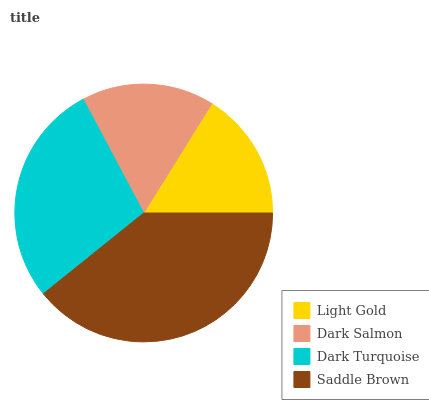Is Light Gold the minimum?
Answer yes or no. Yes. Is Saddle Brown the maximum?
Answer yes or no. Yes. Is Dark Salmon the minimum?
Answer yes or no. No. Is Dark Salmon the maximum?
Answer yes or no. No. Is Dark Salmon greater than Light Gold?
Answer yes or no. Yes. Is Light Gold less than Dark Salmon?
Answer yes or no. Yes. Is Light Gold greater than Dark Salmon?
Answer yes or no. No. Is Dark Salmon less than Light Gold?
Answer yes or no. No. Is Dark Turquoise the high median?
Answer yes or no. Yes. Is Dark Salmon the low median?
Answer yes or no. Yes. Is Dark Salmon the high median?
Answer yes or no. No. Is Light Gold the low median?
Answer yes or no. No. 